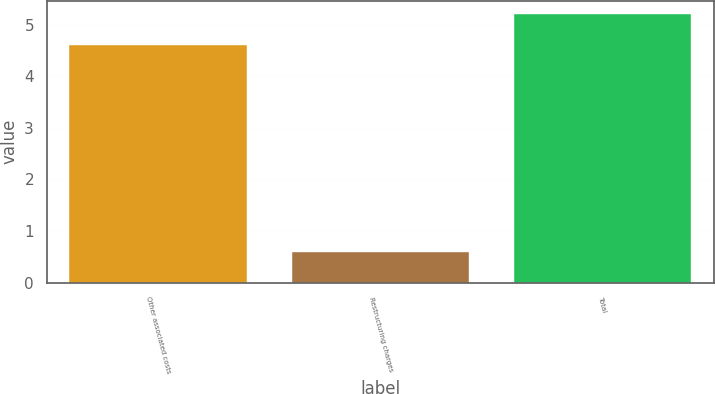Convert chart. <chart><loc_0><loc_0><loc_500><loc_500><bar_chart><fcel>Other associated costs<fcel>Restructuring charges<fcel>Total<nl><fcel>4.6<fcel>0.6<fcel>5.2<nl></chart> 